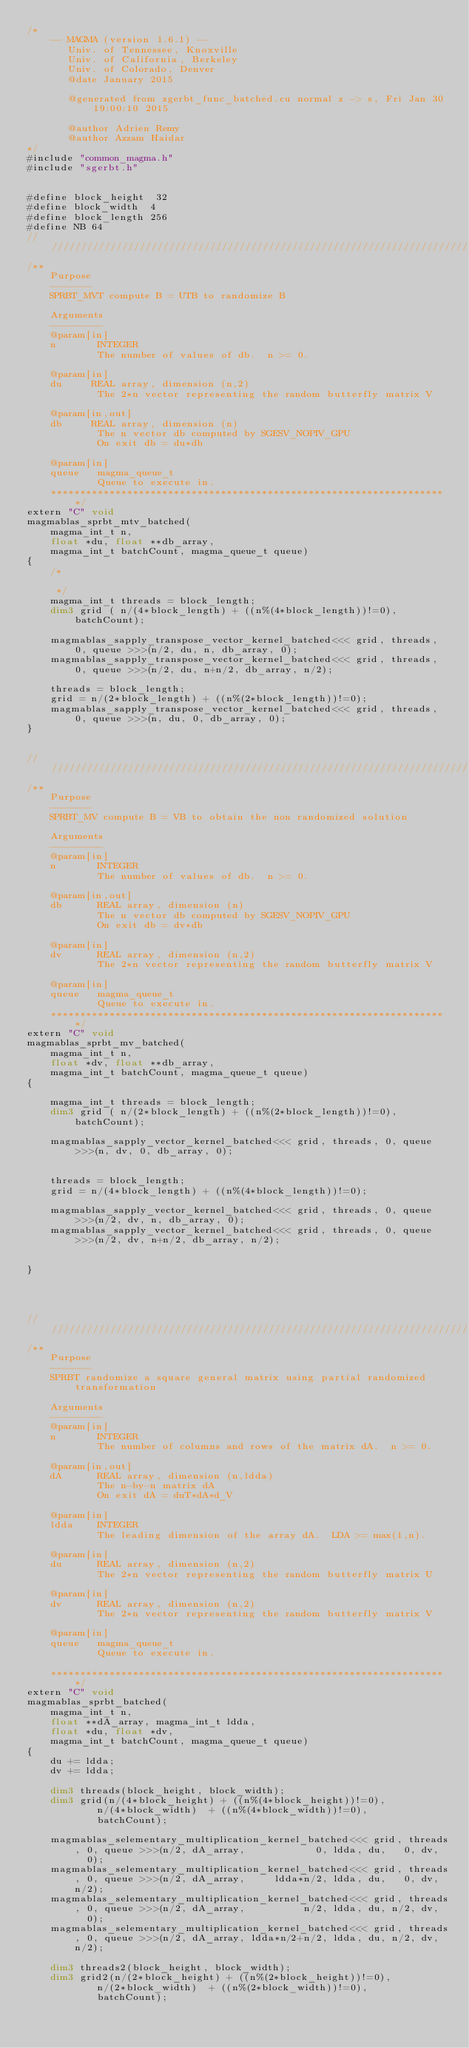<code> <loc_0><loc_0><loc_500><loc_500><_Cuda_>/*
    -- MAGMA (version 1.6.1) --
       Univ. of Tennessee, Knoxville
       Univ. of California, Berkeley
       Univ. of Colorado, Denver
       @date January 2015

       @generated from zgerbt_func_batched.cu normal z -> s, Fri Jan 30 19:00:10 2015

       @author Adrien Remy
       @author Azzam Haidar
*/
#include "common_magma.h"
#include "sgerbt.h"


#define block_height  32
#define block_width  4
#define block_length 256
#define NB 64
/////////////////////////////////////////////////////////////////////////////////////////////////////////////
/**
    Purpose
    -------
    SPRBT_MVT compute B = UTB to randomize B
    
    Arguments
    ---------
    @param[in]
    n       INTEGER
            The number of values of db.  n >= 0.

    @param[in]
    du     REAL array, dimension (n,2)
            The 2*n vector representing the random butterfly matrix V
    
    @param[in,out]
    db     REAL array, dimension (n)
            The n vector db computed by SGESV_NOPIV_GPU
            On exit db = du*db
    
    @param[in]
    queue   magma_queue_t
            Queue to execute in.
    ********************************************************************/
extern "C" void
magmablas_sprbt_mtv_batched(
    magma_int_t n, 
    float *du, float **db_array,
    magma_int_t batchCount, magma_queue_t queue)
{
    /*

     */
    magma_int_t threads = block_length;
    dim3 grid ( n/(4*block_length) + ((n%(4*block_length))!=0), batchCount);

    magmablas_sapply_transpose_vector_kernel_batched<<< grid, threads, 0, queue >>>(n/2, du, n, db_array, 0);
    magmablas_sapply_transpose_vector_kernel_batched<<< grid, threads, 0, queue >>>(n/2, du, n+n/2, db_array, n/2);

    threads = block_length;
    grid = n/(2*block_length) + ((n%(2*block_length))!=0);
    magmablas_sapply_transpose_vector_kernel_batched<<< grid, threads, 0, queue >>>(n, du, 0, db_array, 0);
}


/////////////////////////////////////////////////////////////////////////////////////////////////////////////
/**
    Purpose
    -------
    SPRBT_MV compute B = VB to obtain the non randomized solution
    
    Arguments
    ---------
    @param[in]
    n       INTEGER
            The number of values of db.  n >= 0.
    
    @param[in,out]
    db      REAL array, dimension (n)
            The n vector db computed by SGESV_NOPIV_GPU
            On exit db = dv*db
    
    @param[in]
    dv      REAL array, dimension (n,2)
            The 2*n vector representing the random butterfly matrix V
    
    @param[in]
    queue   magma_queue_t
            Queue to execute in.
    ********************************************************************/
extern "C" void
magmablas_sprbt_mv_batched(
    magma_int_t n, 
    float *dv, float **db_array,
    magma_int_t batchCount, magma_queue_t queue)
{

    magma_int_t threads = block_length;
    dim3 grid ( n/(2*block_length) + ((n%(2*block_length))!=0), batchCount);

    magmablas_sapply_vector_kernel_batched<<< grid, threads, 0, queue >>>(n, dv, 0, db_array, 0);


    threads = block_length;
    grid = n/(4*block_length) + ((n%(4*block_length))!=0);

    magmablas_sapply_vector_kernel_batched<<< grid, threads, 0, queue >>>(n/2, dv, n, db_array, 0);
    magmablas_sapply_vector_kernel_batched<<< grid, threads, 0, queue >>>(n/2, dv, n+n/2, db_array, n/2);


}




/////////////////////////////////////////////////////////////////////////////////////////////////////////////
/**
    Purpose
    -------
    SPRBT randomize a square general matrix using partial randomized transformation
    
    Arguments
    ---------
    @param[in]
    n       INTEGER
            The number of columns and rows of the matrix dA.  n >= 0.
    
    @param[in,out]
    dA      REAL array, dimension (n,ldda)
            The n-by-n matrix dA
            On exit dA = duT*dA*d_V
    
    @param[in]
    ldda    INTEGER
            The leading dimension of the array dA.  LDA >= max(1,n).
    
    @param[in]
    du      REAL array, dimension (n,2)
            The 2*n vector representing the random butterfly matrix U
    
    @param[in]
    dv      REAL array, dimension (n,2)
            The 2*n vector representing the random butterfly matrix V
    
    @param[in]
    queue   magma_queue_t
            Queue to execute in.

    ********************************************************************/
extern "C" void 
magmablas_sprbt_batched(
    magma_int_t n, 
    float **dA_array, magma_int_t ldda, 
    float *du, float *dv,
    magma_int_t batchCount, magma_queue_t queue)
{
    du += ldda;
    dv += ldda;

    dim3 threads(block_height, block_width);
    dim3 grid(n/(4*block_height) + ((n%(4*block_height))!=0), 
            n/(4*block_width)  + ((n%(4*block_width))!=0),
            batchCount);

    magmablas_selementary_multiplication_kernel_batched<<< grid, threads, 0, queue >>>(n/2, dA_array,            0, ldda, du,   0, dv,   0);
    magmablas_selementary_multiplication_kernel_batched<<< grid, threads, 0, queue >>>(n/2, dA_array,     ldda*n/2, ldda, du,   0, dv, n/2);
    magmablas_selementary_multiplication_kernel_batched<<< grid, threads, 0, queue >>>(n/2, dA_array,          n/2, ldda, du, n/2, dv,   0);
    magmablas_selementary_multiplication_kernel_batched<<< grid, threads, 0, queue >>>(n/2, dA_array, ldda*n/2+n/2, ldda, du, n/2, dv, n/2);

    dim3 threads2(block_height, block_width);
    dim3 grid2(n/(2*block_height) + ((n%(2*block_height))!=0), 
            n/(2*block_width)  + ((n%(2*block_width))!=0),
            batchCount);</code> 